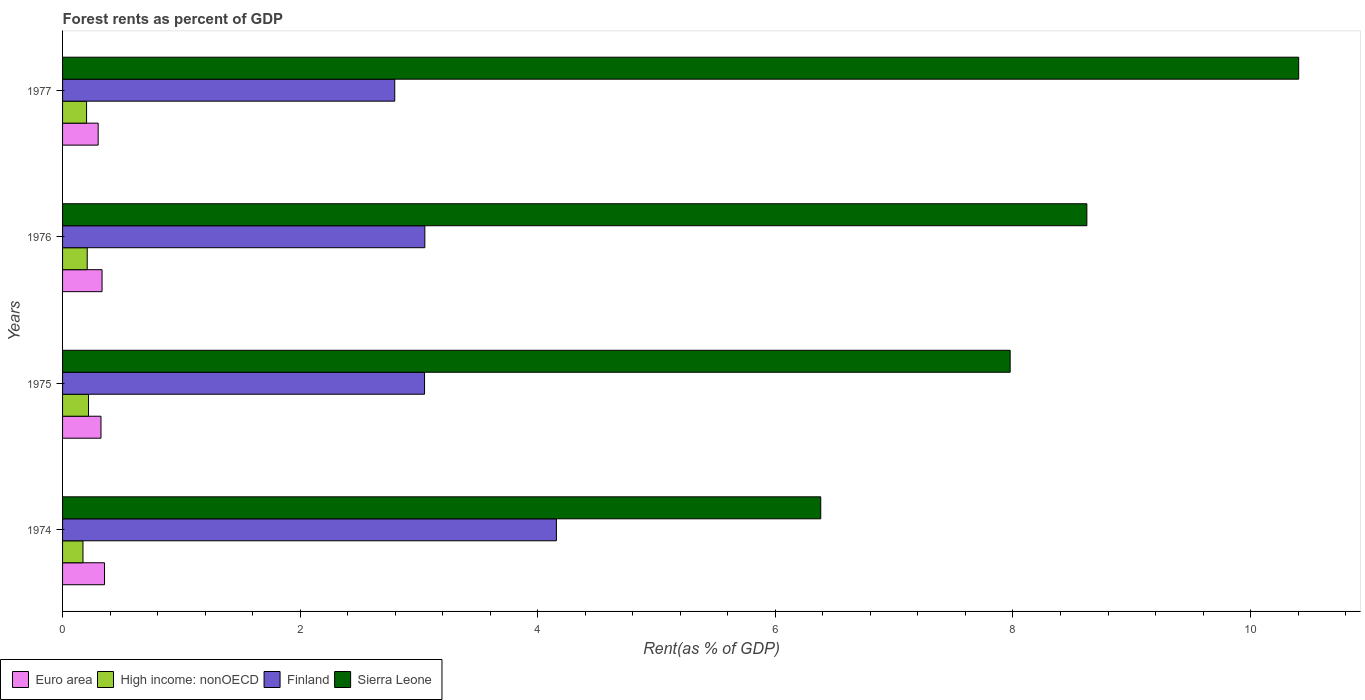How many different coloured bars are there?
Give a very brief answer. 4. What is the label of the 3rd group of bars from the top?
Give a very brief answer. 1975. What is the forest rent in High income: nonOECD in 1975?
Keep it short and to the point. 0.22. Across all years, what is the maximum forest rent in Euro area?
Give a very brief answer. 0.35. Across all years, what is the minimum forest rent in High income: nonOECD?
Your answer should be compact. 0.17. In which year was the forest rent in Euro area minimum?
Offer a terse response. 1977. What is the total forest rent in Sierra Leone in the graph?
Provide a succinct answer. 33.38. What is the difference between the forest rent in High income: nonOECD in 1975 and that in 1977?
Your answer should be very brief. 0.02. What is the difference between the forest rent in Euro area in 1977 and the forest rent in Sierra Leone in 1975?
Provide a short and direct response. -7.68. What is the average forest rent in Euro area per year?
Your answer should be very brief. 0.33. In the year 1976, what is the difference between the forest rent in Sierra Leone and forest rent in Euro area?
Give a very brief answer. 8.29. What is the ratio of the forest rent in High income: nonOECD in 1974 to that in 1976?
Give a very brief answer. 0.83. Is the forest rent in Euro area in 1975 less than that in 1976?
Your answer should be compact. Yes. What is the difference between the highest and the second highest forest rent in High income: nonOECD?
Offer a terse response. 0.01. What is the difference between the highest and the lowest forest rent in High income: nonOECD?
Offer a terse response. 0.05. In how many years, is the forest rent in Euro area greater than the average forest rent in Euro area taken over all years?
Keep it short and to the point. 2. What does the 3rd bar from the top in 1976 represents?
Make the answer very short. High income: nonOECD. Is it the case that in every year, the sum of the forest rent in High income: nonOECD and forest rent in Finland is greater than the forest rent in Sierra Leone?
Your answer should be compact. No. How many bars are there?
Make the answer very short. 16. Are the values on the major ticks of X-axis written in scientific E-notation?
Offer a very short reply. No. Does the graph contain grids?
Your answer should be very brief. No. How many legend labels are there?
Your answer should be very brief. 4. How are the legend labels stacked?
Your response must be concise. Horizontal. What is the title of the graph?
Ensure brevity in your answer.  Forest rents as percent of GDP. What is the label or title of the X-axis?
Offer a terse response. Rent(as % of GDP). What is the Rent(as % of GDP) in Euro area in 1974?
Provide a succinct answer. 0.35. What is the Rent(as % of GDP) in High income: nonOECD in 1974?
Your answer should be compact. 0.17. What is the Rent(as % of GDP) of Finland in 1974?
Make the answer very short. 4.16. What is the Rent(as % of GDP) in Sierra Leone in 1974?
Make the answer very short. 6.38. What is the Rent(as % of GDP) of Euro area in 1975?
Your answer should be very brief. 0.32. What is the Rent(as % of GDP) of High income: nonOECD in 1975?
Make the answer very short. 0.22. What is the Rent(as % of GDP) of Finland in 1975?
Your response must be concise. 3.05. What is the Rent(as % of GDP) in Sierra Leone in 1975?
Provide a succinct answer. 7.98. What is the Rent(as % of GDP) of Euro area in 1976?
Ensure brevity in your answer.  0.33. What is the Rent(as % of GDP) in High income: nonOECD in 1976?
Your answer should be very brief. 0.21. What is the Rent(as % of GDP) of Finland in 1976?
Ensure brevity in your answer.  3.05. What is the Rent(as % of GDP) of Sierra Leone in 1976?
Make the answer very short. 8.62. What is the Rent(as % of GDP) in Euro area in 1977?
Give a very brief answer. 0.3. What is the Rent(as % of GDP) in High income: nonOECD in 1977?
Your answer should be compact. 0.2. What is the Rent(as % of GDP) of Finland in 1977?
Keep it short and to the point. 2.8. What is the Rent(as % of GDP) in Sierra Leone in 1977?
Offer a terse response. 10.4. Across all years, what is the maximum Rent(as % of GDP) in Euro area?
Offer a terse response. 0.35. Across all years, what is the maximum Rent(as % of GDP) of High income: nonOECD?
Your answer should be compact. 0.22. Across all years, what is the maximum Rent(as % of GDP) of Finland?
Give a very brief answer. 4.16. Across all years, what is the maximum Rent(as % of GDP) of Sierra Leone?
Give a very brief answer. 10.4. Across all years, what is the minimum Rent(as % of GDP) in Euro area?
Provide a succinct answer. 0.3. Across all years, what is the minimum Rent(as % of GDP) in High income: nonOECD?
Your answer should be very brief. 0.17. Across all years, what is the minimum Rent(as % of GDP) of Finland?
Ensure brevity in your answer.  2.8. Across all years, what is the minimum Rent(as % of GDP) in Sierra Leone?
Give a very brief answer. 6.38. What is the total Rent(as % of GDP) in Euro area in the graph?
Offer a very short reply. 1.31. What is the total Rent(as % of GDP) in High income: nonOECD in the graph?
Your response must be concise. 0.8. What is the total Rent(as % of GDP) in Finland in the graph?
Provide a succinct answer. 13.05. What is the total Rent(as % of GDP) in Sierra Leone in the graph?
Your answer should be very brief. 33.38. What is the difference between the Rent(as % of GDP) of Euro area in 1974 and that in 1975?
Your answer should be very brief. 0.03. What is the difference between the Rent(as % of GDP) in High income: nonOECD in 1974 and that in 1975?
Keep it short and to the point. -0.05. What is the difference between the Rent(as % of GDP) of Finland in 1974 and that in 1975?
Your answer should be very brief. 1.11. What is the difference between the Rent(as % of GDP) of Sierra Leone in 1974 and that in 1975?
Your response must be concise. -1.59. What is the difference between the Rent(as % of GDP) in Euro area in 1974 and that in 1976?
Offer a terse response. 0.02. What is the difference between the Rent(as % of GDP) of High income: nonOECD in 1974 and that in 1976?
Your answer should be very brief. -0.04. What is the difference between the Rent(as % of GDP) in Finland in 1974 and that in 1976?
Give a very brief answer. 1.11. What is the difference between the Rent(as % of GDP) in Sierra Leone in 1974 and that in 1976?
Provide a short and direct response. -2.24. What is the difference between the Rent(as % of GDP) in Euro area in 1974 and that in 1977?
Provide a succinct answer. 0.05. What is the difference between the Rent(as % of GDP) in High income: nonOECD in 1974 and that in 1977?
Ensure brevity in your answer.  -0.03. What is the difference between the Rent(as % of GDP) of Finland in 1974 and that in 1977?
Your answer should be compact. 1.36. What is the difference between the Rent(as % of GDP) in Sierra Leone in 1974 and that in 1977?
Your answer should be compact. -4.02. What is the difference between the Rent(as % of GDP) of Euro area in 1975 and that in 1976?
Ensure brevity in your answer.  -0.01. What is the difference between the Rent(as % of GDP) in High income: nonOECD in 1975 and that in 1976?
Provide a succinct answer. 0.01. What is the difference between the Rent(as % of GDP) of Finland in 1975 and that in 1976?
Provide a succinct answer. -0. What is the difference between the Rent(as % of GDP) of Sierra Leone in 1975 and that in 1976?
Provide a short and direct response. -0.65. What is the difference between the Rent(as % of GDP) of Euro area in 1975 and that in 1977?
Your answer should be compact. 0.02. What is the difference between the Rent(as % of GDP) of High income: nonOECD in 1975 and that in 1977?
Provide a succinct answer. 0.02. What is the difference between the Rent(as % of GDP) of Finland in 1975 and that in 1977?
Offer a very short reply. 0.25. What is the difference between the Rent(as % of GDP) of Sierra Leone in 1975 and that in 1977?
Your response must be concise. -2.43. What is the difference between the Rent(as % of GDP) of Euro area in 1976 and that in 1977?
Your answer should be compact. 0.03. What is the difference between the Rent(as % of GDP) in High income: nonOECD in 1976 and that in 1977?
Ensure brevity in your answer.  0.01. What is the difference between the Rent(as % of GDP) of Finland in 1976 and that in 1977?
Ensure brevity in your answer.  0.25. What is the difference between the Rent(as % of GDP) in Sierra Leone in 1976 and that in 1977?
Provide a succinct answer. -1.78. What is the difference between the Rent(as % of GDP) of Euro area in 1974 and the Rent(as % of GDP) of High income: nonOECD in 1975?
Give a very brief answer. 0.13. What is the difference between the Rent(as % of GDP) in Euro area in 1974 and the Rent(as % of GDP) in Finland in 1975?
Your answer should be very brief. -2.69. What is the difference between the Rent(as % of GDP) of Euro area in 1974 and the Rent(as % of GDP) of Sierra Leone in 1975?
Your answer should be compact. -7.62. What is the difference between the Rent(as % of GDP) of High income: nonOECD in 1974 and the Rent(as % of GDP) of Finland in 1975?
Give a very brief answer. -2.88. What is the difference between the Rent(as % of GDP) of High income: nonOECD in 1974 and the Rent(as % of GDP) of Sierra Leone in 1975?
Give a very brief answer. -7.8. What is the difference between the Rent(as % of GDP) of Finland in 1974 and the Rent(as % of GDP) of Sierra Leone in 1975?
Your response must be concise. -3.82. What is the difference between the Rent(as % of GDP) in Euro area in 1974 and the Rent(as % of GDP) in High income: nonOECD in 1976?
Your answer should be compact. 0.15. What is the difference between the Rent(as % of GDP) of Euro area in 1974 and the Rent(as % of GDP) of Finland in 1976?
Give a very brief answer. -2.7. What is the difference between the Rent(as % of GDP) of Euro area in 1974 and the Rent(as % of GDP) of Sierra Leone in 1976?
Offer a very short reply. -8.27. What is the difference between the Rent(as % of GDP) of High income: nonOECD in 1974 and the Rent(as % of GDP) of Finland in 1976?
Your answer should be compact. -2.88. What is the difference between the Rent(as % of GDP) in High income: nonOECD in 1974 and the Rent(as % of GDP) in Sierra Leone in 1976?
Provide a succinct answer. -8.45. What is the difference between the Rent(as % of GDP) of Finland in 1974 and the Rent(as % of GDP) of Sierra Leone in 1976?
Offer a very short reply. -4.46. What is the difference between the Rent(as % of GDP) of Euro area in 1974 and the Rent(as % of GDP) of High income: nonOECD in 1977?
Provide a succinct answer. 0.15. What is the difference between the Rent(as % of GDP) of Euro area in 1974 and the Rent(as % of GDP) of Finland in 1977?
Ensure brevity in your answer.  -2.44. What is the difference between the Rent(as % of GDP) of Euro area in 1974 and the Rent(as % of GDP) of Sierra Leone in 1977?
Ensure brevity in your answer.  -10.05. What is the difference between the Rent(as % of GDP) of High income: nonOECD in 1974 and the Rent(as % of GDP) of Finland in 1977?
Provide a succinct answer. -2.62. What is the difference between the Rent(as % of GDP) of High income: nonOECD in 1974 and the Rent(as % of GDP) of Sierra Leone in 1977?
Offer a terse response. -10.23. What is the difference between the Rent(as % of GDP) of Finland in 1974 and the Rent(as % of GDP) of Sierra Leone in 1977?
Offer a terse response. -6.25. What is the difference between the Rent(as % of GDP) in Euro area in 1975 and the Rent(as % of GDP) in High income: nonOECD in 1976?
Ensure brevity in your answer.  0.12. What is the difference between the Rent(as % of GDP) in Euro area in 1975 and the Rent(as % of GDP) in Finland in 1976?
Offer a terse response. -2.73. What is the difference between the Rent(as % of GDP) of Euro area in 1975 and the Rent(as % of GDP) of Sierra Leone in 1976?
Give a very brief answer. -8.3. What is the difference between the Rent(as % of GDP) in High income: nonOECD in 1975 and the Rent(as % of GDP) in Finland in 1976?
Your response must be concise. -2.83. What is the difference between the Rent(as % of GDP) in High income: nonOECD in 1975 and the Rent(as % of GDP) in Sierra Leone in 1976?
Offer a very short reply. -8.4. What is the difference between the Rent(as % of GDP) in Finland in 1975 and the Rent(as % of GDP) in Sierra Leone in 1976?
Your response must be concise. -5.57. What is the difference between the Rent(as % of GDP) in Euro area in 1975 and the Rent(as % of GDP) in High income: nonOECD in 1977?
Provide a short and direct response. 0.12. What is the difference between the Rent(as % of GDP) of Euro area in 1975 and the Rent(as % of GDP) of Finland in 1977?
Your answer should be very brief. -2.47. What is the difference between the Rent(as % of GDP) in Euro area in 1975 and the Rent(as % of GDP) in Sierra Leone in 1977?
Provide a succinct answer. -10.08. What is the difference between the Rent(as % of GDP) in High income: nonOECD in 1975 and the Rent(as % of GDP) in Finland in 1977?
Offer a terse response. -2.58. What is the difference between the Rent(as % of GDP) of High income: nonOECD in 1975 and the Rent(as % of GDP) of Sierra Leone in 1977?
Provide a short and direct response. -10.19. What is the difference between the Rent(as % of GDP) in Finland in 1975 and the Rent(as % of GDP) in Sierra Leone in 1977?
Offer a terse response. -7.36. What is the difference between the Rent(as % of GDP) of Euro area in 1976 and the Rent(as % of GDP) of High income: nonOECD in 1977?
Your answer should be compact. 0.13. What is the difference between the Rent(as % of GDP) of Euro area in 1976 and the Rent(as % of GDP) of Finland in 1977?
Provide a short and direct response. -2.46. What is the difference between the Rent(as % of GDP) of Euro area in 1976 and the Rent(as % of GDP) of Sierra Leone in 1977?
Offer a terse response. -10.07. What is the difference between the Rent(as % of GDP) of High income: nonOECD in 1976 and the Rent(as % of GDP) of Finland in 1977?
Your response must be concise. -2.59. What is the difference between the Rent(as % of GDP) in High income: nonOECD in 1976 and the Rent(as % of GDP) in Sierra Leone in 1977?
Ensure brevity in your answer.  -10.2. What is the difference between the Rent(as % of GDP) of Finland in 1976 and the Rent(as % of GDP) of Sierra Leone in 1977?
Keep it short and to the point. -7.36. What is the average Rent(as % of GDP) in Euro area per year?
Ensure brevity in your answer.  0.33. What is the average Rent(as % of GDP) of Finland per year?
Provide a short and direct response. 3.26. What is the average Rent(as % of GDP) in Sierra Leone per year?
Your answer should be very brief. 8.35. In the year 1974, what is the difference between the Rent(as % of GDP) in Euro area and Rent(as % of GDP) in High income: nonOECD?
Give a very brief answer. 0.18. In the year 1974, what is the difference between the Rent(as % of GDP) of Euro area and Rent(as % of GDP) of Finland?
Ensure brevity in your answer.  -3.8. In the year 1974, what is the difference between the Rent(as % of GDP) in Euro area and Rent(as % of GDP) in Sierra Leone?
Give a very brief answer. -6.03. In the year 1974, what is the difference between the Rent(as % of GDP) of High income: nonOECD and Rent(as % of GDP) of Finland?
Make the answer very short. -3.98. In the year 1974, what is the difference between the Rent(as % of GDP) in High income: nonOECD and Rent(as % of GDP) in Sierra Leone?
Make the answer very short. -6.21. In the year 1974, what is the difference between the Rent(as % of GDP) of Finland and Rent(as % of GDP) of Sierra Leone?
Provide a short and direct response. -2.23. In the year 1975, what is the difference between the Rent(as % of GDP) in Euro area and Rent(as % of GDP) in High income: nonOECD?
Provide a short and direct response. 0.1. In the year 1975, what is the difference between the Rent(as % of GDP) in Euro area and Rent(as % of GDP) in Finland?
Ensure brevity in your answer.  -2.72. In the year 1975, what is the difference between the Rent(as % of GDP) in Euro area and Rent(as % of GDP) in Sierra Leone?
Your answer should be very brief. -7.65. In the year 1975, what is the difference between the Rent(as % of GDP) of High income: nonOECD and Rent(as % of GDP) of Finland?
Offer a terse response. -2.83. In the year 1975, what is the difference between the Rent(as % of GDP) of High income: nonOECD and Rent(as % of GDP) of Sierra Leone?
Provide a short and direct response. -7.76. In the year 1975, what is the difference between the Rent(as % of GDP) in Finland and Rent(as % of GDP) in Sierra Leone?
Offer a very short reply. -4.93. In the year 1976, what is the difference between the Rent(as % of GDP) in Euro area and Rent(as % of GDP) in Finland?
Your answer should be very brief. -2.72. In the year 1976, what is the difference between the Rent(as % of GDP) in Euro area and Rent(as % of GDP) in Sierra Leone?
Your answer should be compact. -8.29. In the year 1976, what is the difference between the Rent(as % of GDP) of High income: nonOECD and Rent(as % of GDP) of Finland?
Provide a short and direct response. -2.84. In the year 1976, what is the difference between the Rent(as % of GDP) of High income: nonOECD and Rent(as % of GDP) of Sierra Leone?
Ensure brevity in your answer.  -8.41. In the year 1976, what is the difference between the Rent(as % of GDP) of Finland and Rent(as % of GDP) of Sierra Leone?
Your answer should be very brief. -5.57. In the year 1977, what is the difference between the Rent(as % of GDP) in Euro area and Rent(as % of GDP) in High income: nonOECD?
Keep it short and to the point. 0.1. In the year 1977, what is the difference between the Rent(as % of GDP) in Euro area and Rent(as % of GDP) in Finland?
Your response must be concise. -2.5. In the year 1977, what is the difference between the Rent(as % of GDP) of Euro area and Rent(as % of GDP) of Sierra Leone?
Your answer should be compact. -10.11. In the year 1977, what is the difference between the Rent(as % of GDP) in High income: nonOECD and Rent(as % of GDP) in Finland?
Provide a succinct answer. -2.59. In the year 1977, what is the difference between the Rent(as % of GDP) in High income: nonOECD and Rent(as % of GDP) in Sierra Leone?
Make the answer very short. -10.2. In the year 1977, what is the difference between the Rent(as % of GDP) of Finland and Rent(as % of GDP) of Sierra Leone?
Your answer should be compact. -7.61. What is the ratio of the Rent(as % of GDP) of Euro area in 1974 to that in 1975?
Your response must be concise. 1.09. What is the ratio of the Rent(as % of GDP) in High income: nonOECD in 1974 to that in 1975?
Your response must be concise. 0.79. What is the ratio of the Rent(as % of GDP) of Finland in 1974 to that in 1975?
Offer a terse response. 1.36. What is the ratio of the Rent(as % of GDP) of Sierra Leone in 1974 to that in 1975?
Offer a very short reply. 0.8. What is the ratio of the Rent(as % of GDP) of Euro area in 1974 to that in 1976?
Your answer should be very brief. 1.06. What is the ratio of the Rent(as % of GDP) of High income: nonOECD in 1974 to that in 1976?
Make the answer very short. 0.83. What is the ratio of the Rent(as % of GDP) in Finland in 1974 to that in 1976?
Offer a very short reply. 1.36. What is the ratio of the Rent(as % of GDP) in Sierra Leone in 1974 to that in 1976?
Offer a terse response. 0.74. What is the ratio of the Rent(as % of GDP) in Euro area in 1974 to that in 1977?
Offer a terse response. 1.18. What is the ratio of the Rent(as % of GDP) of High income: nonOECD in 1974 to that in 1977?
Provide a succinct answer. 0.85. What is the ratio of the Rent(as % of GDP) in Finland in 1974 to that in 1977?
Keep it short and to the point. 1.49. What is the ratio of the Rent(as % of GDP) of Sierra Leone in 1974 to that in 1977?
Ensure brevity in your answer.  0.61. What is the ratio of the Rent(as % of GDP) in Euro area in 1975 to that in 1976?
Offer a terse response. 0.97. What is the ratio of the Rent(as % of GDP) of High income: nonOECD in 1975 to that in 1976?
Give a very brief answer. 1.05. What is the ratio of the Rent(as % of GDP) in Sierra Leone in 1975 to that in 1976?
Offer a very short reply. 0.93. What is the ratio of the Rent(as % of GDP) of Euro area in 1975 to that in 1977?
Keep it short and to the point. 1.08. What is the ratio of the Rent(as % of GDP) in High income: nonOECD in 1975 to that in 1977?
Keep it short and to the point. 1.08. What is the ratio of the Rent(as % of GDP) of Finland in 1975 to that in 1977?
Your response must be concise. 1.09. What is the ratio of the Rent(as % of GDP) in Sierra Leone in 1975 to that in 1977?
Ensure brevity in your answer.  0.77. What is the ratio of the Rent(as % of GDP) of Euro area in 1976 to that in 1977?
Give a very brief answer. 1.11. What is the ratio of the Rent(as % of GDP) of High income: nonOECD in 1976 to that in 1977?
Provide a succinct answer. 1.03. What is the ratio of the Rent(as % of GDP) of Finland in 1976 to that in 1977?
Offer a very short reply. 1.09. What is the ratio of the Rent(as % of GDP) of Sierra Leone in 1976 to that in 1977?
Your answer should be very brief. 0.83. What is the difference between the highest and the second highest Rent(as % of GDP) in Euro area?
Ensure brevity in your answer.  0.02. What is the difference between the highest and the second highest Rent(as % of GDP) of High income: nonOECD?
Offer a very short reply. 0.01. What is the difference between the highest and the second highest Rent(as % of GDP) of Finland?
Your answer should be compact. 1.11. What is the difference between the highest and the second highest Rent(as % of GDP) of Sierra Leone?
Give a very brief answer. 1.78. What is the difference between the highest and the lowest Rent(as % of GDP) of Euro area?
Your answer should be compact. 0.05. What is the difference between the highest and the lowest Rent(as % of GDP) in High income: nonOECD?
Make the answer very short. 0.05. What is the difference between the highest and the lowest Rent(as % of GDP) of Finland?
Give a very brief answer. 1.36. What is the difference between the highest and the lowest Rent(as % of GDP) of Sierra Leone?
Provide a short and direct response. 4.02. 